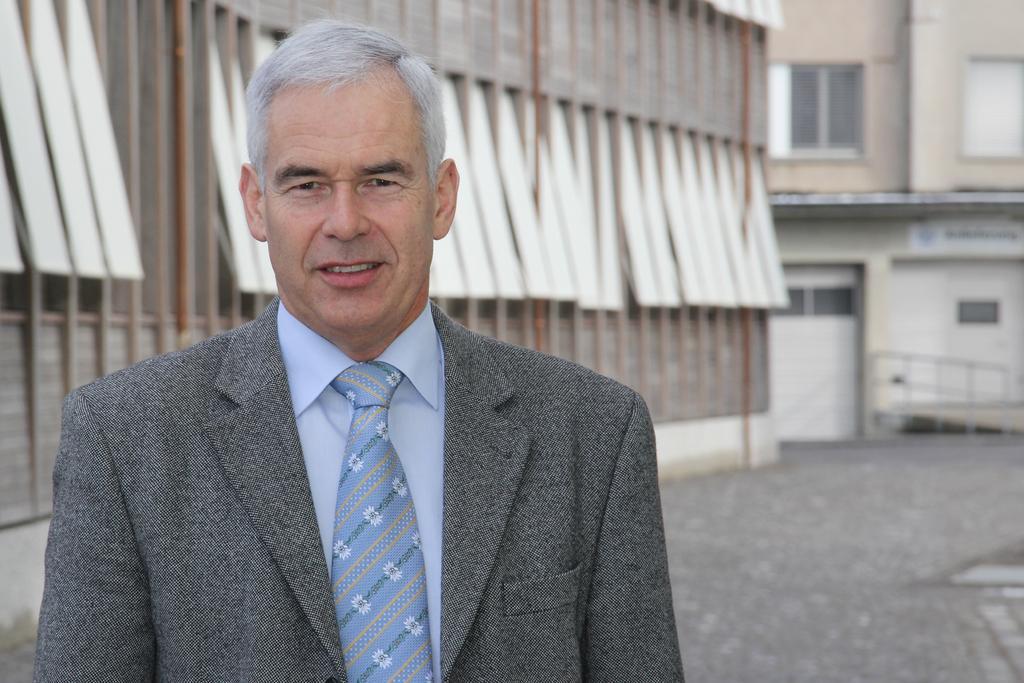Can you describe this image briefly? In this image we can see a person standing with a smile on his face, the back of this person there are buildings. 